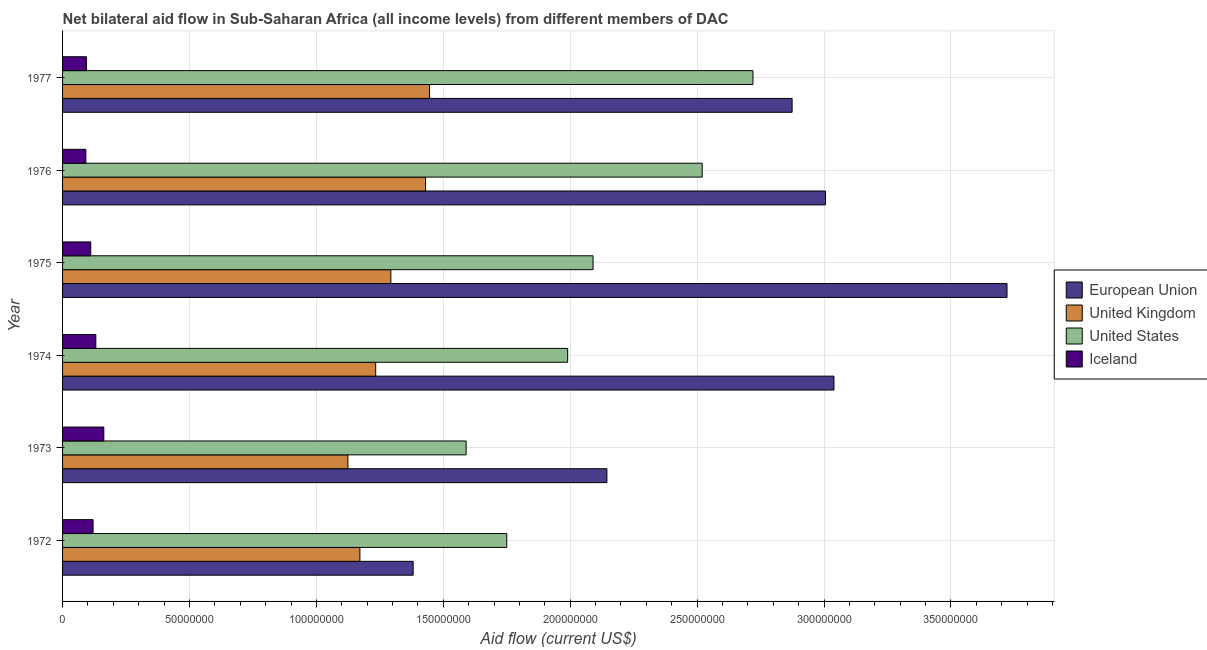Are the number of bars on each tick of the Y-axis equal?
Keep it short and to the point. Yes. How many bars are there on the 3rd tick from the top?
Offer a very short reply. 4. How many bars are there on the 2nd tick from the bottom?
Your answer should be compact. 4. What is the label of the 1st group of bars from the top?
Offer a very short reply. 1977. What is the amount of aid given by uk in 1976?
Make the answer very short. 1.43e+08. Across all years, what is the maximum amount of aid given by us?
Keep it short and to the point. 2.72e+08. Across all years, what is the minimum amount of aid given by us?
Your response must be concise. 1.59e+08. In which year was the amount of aid given by iceland maximum?
Provide a short and direct response. 1973. What is the total amount of aid given by iceland in the graph?
Keep it short and to the point. 7.10e+07. What is the difference between the amount of aid given by iceland in 1972 and that in 1973?
Offer a very short reply. -4.23e+06. What is the difference between the amount of aid given by us in 1972 and the amount of aid given by uk in 1976?
Your response must be concise. 3.20e+07. What is the average amount of aid given by iceland per year?
Keep it short and to the point. 1.18e+07. In the year 1974, what is the difference between the amount of aid given by eu and amount of aid given by us?
Your response must be concise. 1.05e+08. In how many years, is the amount of aid given by us greater than 160000000 US$?
Your answer should be very brief. 5. What is the ratio of the amount of aid given by us in 1972 to that in 1973?
Offer a very short reply. 1.1. Is the amount of aid given by us in 1972 less than that in 1974?
Offer a terse response. Yes. What is the difference between the highest and the second highest amount of aid given by eu?
Keep it short and to the point. 6.82e+07. What is the difference between the highest and the lowest amount of aid given by uk?
Your answer should be compact. 3.22e+07. In how many years, is the amount of aid given by iceland greater than the average amount of aid given by iceland taken over all years?
Provide a succinct answer. 3. Is it the case that in every year, the sum of the amount of aid given by uk and amount of aid given by eu is greater than the sum of amount of aid given by iceland and amount of aid given by us?
Your answer should be very brief. Yes. What does the 3rd bar from the top in 1977 represents?
Make the answer very short. United Kingdom. How many bars are there?
Your answer should be compact. 24. Are all the bars in the graph horizontal?
Your answer should be compact. Yes. Are the values on the major ticks of X-axis written in scientific E-notation?
Offer a very short reply. No. Does the graph contain grids?
Provide a short and direct response. Yes. How many legend labels are there?
Your answer should be compact. 4. What is the title of the graph?
Offer a very short reply. Net bilateral aid flow in Sub-Saharan Africa (all income levels) from different members of DAC. What is the label or title of the X-axis?
Your answer should be compact. Aid flow (current US$). What is the label or title of the Y-axis?
Make the answer very short. Year. What is the Aid flow (current US$) in European Union in 1972?
Give a very brief answer. 1.38e+08. What is the Aid flow (current US$) in United Kingdom in 1972?
Your answer should be compact. 1.17e+08. What is the Aid flow (current US$) of United States in 1972?
Offer a very short reply. 1.75e+08. What is the Aid flow (current US$) in Iceland in 1972?
Offer a terse response. 1.20e+07. What is the Aid flow (current US$) in European Union in 1973?
Your response must be concise. 2.14e+08. What is the Aid flow (current US$) in United Kingdom in 1973?
Your answer should be very brief. 1.12e+08. What is the Aid flow (current US$) in United States in 1973?
Offer a very short reply. 1.59e+08. What is the Aid flow (current US$) in Iceland in 1973?
Your answer should be very brief. 1.62e+07. What is the Aid flow (current US$) in European Union in 1974?
Your answer should be compact. 3.04e+08. What is the Aid flow (current US$) of United Kingdom in 1974?
Keep it short and to the point. 1.23e+08. What is the Aid flow (current US$) of United States in 1974?
Offer a terse response. 1.99e+08. What is the Aid flow (current US$) in Iceland in 1974?
Your answer should be very brief. 1.31e+07. What is the Aid flow (current US$) of European Union in 1975?
Offer a terse response. 3.72e+08. What is the Aid flow (current US$) of United Kingdom in 1975?
Give a very brief answer. 1.29e+08. What is the Aid flow (current US$) in United States in 1975?
Offer a very short reply. 2.09e+08. What is the Aid flow (current US$) of Iceland in 1975?
Your response must be concise. 1.11e+07. What is the Aid flow (current US$) of European Union in 1976?
Offer a very short reply. 3.01e+08. What is the Aid flow (current US$) of United Kingdom in 1976?
Provide a short and direct response. 1.43e+08. What is the Aid flow (current US$) of United States in 1976?
Make the answer very short. 2.52e+08. What is the Aid flow (current US$) of Iceland in 1976?
Ensure brevity in your answer.  9.18e+06. What is the Aid flow (current US$) of European Union in 1977?
Your answer should be compact. 2.87e+08. What is the Aid flow (current US$) in United Kingdom in 1977?
Offer a very short reply. 1.45e+08. What is the Aid flow (current US$) of United States in 1977?
Offer a terse response. 2.72e+08. What is the Aid flow (current US$) in Iceland in 1977?
Offer a very short reply. 9.40e+06. Across all years, what is the maximum Aid flow (current US$) of European Union?
Give a very brief answer. 3.72e+08. Across all years, what is the maximum Aid flow (current US$) of United Kingdom?
Give a very brief answer. 1.45e+08. Across all years, what is the maximum Aid flow (current US$) in United States?
Offer a terse response. 2.72e+08. Across all years, what is the maximum Aid flow (current US$) in Iceland?
Provide a succinct answer. 1.62e+07. Across all years, what is the minimum Aid flow (current US$) of European Union?
Keep it short and to the point. 1.38e+08. Across all years, what is the minimum Aid flow (current US$) of United Kingdom?
Provide a succinct answer. 1.12e+08. Across all years, what is the minimum Aid flow (current US$) of United States?
Keep it short and to the point. 1.59e+08. Across all years, what is the minimum Aid flow (current US$) in Iceland?
Your answer should be compact. 9.18e+06. What is the total Aid flow (current US$) of European Union in the graph?
Offer a very short reply. 1.62e+09. What is the total Aid flow (current US$) in United Kingdom in the graph?
Make the answer very short. 7.70e+08. What is the total Aid flow (current US$) in United States in the graph?
Keep it short and to the point. 1.27e+09. What is the total Aid flow (current US$) in Iceland in the graph?
Your response must be concise. 7.10e+07. What is the difference between the Aid flow (current US$) in European Union in 1972 and that in 1973?
Offer a terse response. -7.63e+07. What is the difference between the Aid flow (current US$) of United Kingdom in 1972 and that in 1973?
Give a very brief answer. 4.72e+06. What is the difference between the Aid flow (current US$) in United States in 1972 and that in 1973?
Your response must be concise. 1.60e+07. What is the difference between the Aid flow (current US$) of Iceland in 1972 and that in 1973?
Give a very brief answer. -4.23e+06. What is the difference between the Aid flow (current US$) in European Union in 1972 and that in 1974?
Your answer should be compact. -1.66e+08. What is the difference between the Aid flow (current US$) in United Kingdom in 1972 and that in 1974?
Provide a succinct answer. -6.23e+06. What is the difference between the Aid flow (current US$) in United States in 1972 and that in 1974?
Your response must be concise. -2.40e+07. What is the difference between the Aid flow (current US$) of Iceland in 1972 and that in 1974?
Your answer should be compact. -1.08e+06. What is the difference between the Aid flow (current US$) in European Union in 1972 and that in 1975?
Your answer should be very brief. -2.34e+08. What is the difference between the Aid flow (current US$) in United Kingdom in 1972 and that in 1975?
Ensure brevity in your answer.  -1.22e+07. What is the difference between the Aid flow (current US$) of United States in 1972 and that in 1975?
Provide a short and direct response. -3.40e+07. What is the difference between the Aid flow (current US$) in Iceland in 1972 and that in 1975?
Give a very brief answer. 9.20e+05. What is the difference between the Aid flow (current US$) of European Union in 1972 and that in 1976?
Your answer should be compact. -1.62e+08. What is the difference between the Aid flow (current US$) in United Kingdom in 1972 and that in 1976?
Your answer should be compact. -2.59e+07. What is the difference between the Aid flow (current US$) in United States in 1972 and that in 1976?
Provide a short and direct response. -7.70e+07. What is the difference between the Aid flow (current US$) in Iceland in 1972 and that in 1976?
Provide a short and direct response. 2.84e+06. What is the difference between the Aid flow (current US$) in European Union in 1972 and that in 1977?
Your answer should be very brief. -1.49e+08. What is the difference between the Aid flow (current US$) in United Kingdom in 1972 and that in 1977?
Provide a succinct answer. -2.74e+07. What is the difference between the Aid flow (current US$) of United States in 1972 and that in 1977?
Give a very brief answer. -9.70e+07. What is the difference between the Aid flow (current US$) of Iceland in 1972 and that in 1977?
Ensure brevity in your answer.  2.62e+06. What is the difference between the Aid flow (current US$) in European Union in 1973 and that in 1974?
Give a very brief answer. -8.95e+07. What is the difference between the Aid flow (current US$) in United Kingdom in 1973 and that in 1974?
Make the answer very short. -1.10e+07. What is the difference between the Aid flow (current US$) of United States in 1973 and that in 1974?
Give a very brief answer. -4.00e+07. What is the difference between the Aid flow (current US$) in Iceland in 1973 and that in 1974?
Provide a short and direct response. 3.15e+06. What is the difference between the Aid flow (current US$) in European Union in 1973 and that in 1975?
Your answer should be very brief. -1.58e+08. What is the difference between the Aid flow (current US$) of United Kingdom in 1973 and that in 1975?
Your answer should be compact. -1.69e+07. What is the difference between the Aid flow (current US$) in United States in 1973 and that in 1975?
Offer a terse response. -5.00e+07. What is the difference between the Aid flow (current US$) in Iceland in 1973 and that in 1975?
Provide a succinct answer. 5.15e+06. What is the difference between the Aid flow (current US$) of European Union in 1973 and that in 1976?
Offer a terse response. -8.61e+07. What is the difference between the Aid flow (current US$) in United Kingdom in 1973 and that in 1976?
Your answer should be very brief. -3.06e+07. What is the difference between the Aid flow (current US$) in United States in 1973 and that in 1976?
Your answer should be compact. -9.30e+07. What is the difference between the Aid flow (current US$) of Iceland in 1973 and that in 1976?
Provide a succinct answer. 7.07e+06. What is the difference between the Aid flow (current US$) in European Union in 1973 and that in 1977?
Offer a very short reply. -7.30e+07. What is the difference between the Aid flow (current US$) of United Kingdom in 1973 and that in 1977?
Offer a terse response. -3.22e+07. What is the difference between the Aid flow (current US$) of United States in 1973 and that in 1977?
Keep it short and to the point. -1.13e+08. What is the difference between the Aid flow (current US$) in Iceland in 1973 and that in 1977?
Keep it short and to the point. 6.85e+06. What is the difference between the Aid flow (current US$) of European Union in 1974 and that in 1975?
Offer a terse response. -6.82e+07. What is the difference between the Aid flow (current US$) of United Kingdom in 1974 and that in 1975?
Make the answer very short. -5.97e+06. What is the difference between the Aid flow (current US$) of United States in 1974 and that in 1975?
Provide a short and direct response. -1.00e+07. What is the difference between the Aid flow (current US$) in European Union in 1974 and that in 1976?
Your answer should be very brief. 3.34e+06. What is the difference between the Aid flow (current US$) of United Kingdom in 1974 and that in 1976?
Your answer should be very brief. -1.96e+07. What is the difference between the Aid flow (current US$) of United States in 1974 and that in 1976?
Your answer should be compact. -5.30e+07. What is the difference between the Aid flow (current US$) in Iceland in 1974 and that in 1976?
Provide a short and direct response. 3.92e+06. What is the difference between the Aid flow (current US$) in European Union in 1974 and that in 1977?
Your answer should be very brief. 1.65e+07. What is the difference between the Aid flow (current US$) in United Kingdom in 1974 and that in 1977?
Make the answer very short. -2.12e+07. What is the difference between the Aid flow (current US$) in United States in 1974 and that in 1977?
Your answer should be compact. -7.30e+07. What is the difference between the Aid flow (current US$) in Iceland in 1974 and that in 1977?
Provide a short and direct response. 3.70e+06. What is the difference between the Aid flow (current US$) in European Union in 1975 and that in 1976?
Provide a succinct answer. 7.15e+07. What is the difference between the Aid flow (current US$) of United Kingdom in 1975 and that in 1976?
Your answer should be very brief. -1.37e+07. What is the difference between the Aid flow (current US$) of United States in 1975 and that in 1976?
Provide a succinct answer. -4.30e+07. What is the difference between the Aid flow (current US$) in Iceland in 1975 and that in 1976?
Provide a succinct answer. 1.92e+06. What is the difference between the Aid flow (current US$) of European Union in 1975 and that in 1977?
Make the answer very short. 8.47e+07. What is the difference between the Aid flow (current US$) in United Kingdom in 1975 and that in 1977?
Give a very brief answer. -1.52e+07. What is the difference between the Aid flow (current US$) of United States in 1975 and that in 1977?
Keep it short and to the point. -6.30e+07. What is the difference between the Aid flow (current US$) of Iceland in 1975 and that in 1977?
Offer a terse response. 1.70e+06. What is the difference between the Aid flow (current US$) of European Union in 1976 and that in 1977?
Your response must be concise. 1.32e+07. What is the difference between the Aid flow (current US$) in United Kingdom in 1976 and that in 1977?
Make the answer very short. -1.58e+06. What is the difference between the Aid flow (current US$) of United States in 1976 and that in 1977?
Offer a very short reply. -2.00e+07. What is the difference between the Aid flow (current US$) of Iceland in 1976 and that in 1977?
Your answer should be compact. -2.20e+05. What is the difference between the Aid flow (current US$) in European Union in 1972 and the Aid flow (current US$) in United Kingdom in 1973?
Ensure brevity in your answer.  2.57e+07. What is the difference between the Aid flow (current US$) in European Union in 1972 and the Aid flow (current US$) in United States in 1973?
Provide a succinct answer. -2.09e+07. What is the difference between the Aid flow (current US$) in European Union in 1972 and the Aid flow (current US$) in Iceland in 1973?
Your answer should be very brief. 1.22e+08. What is the difference between the Aid flow (current US$) in United Kingdom in 1972 and the Aid flow (current US$) in United States in 1973?
Provide a short and direct response. -4.19e+07. What is the difference between the Aid flow (current US$) in United Kingdom in 1972 and the Aid flow (current US$) in Iceland in 1973?
Provide a succinct answer. 1.01e+08. What is the difference between the Aid flow (current US$) in United States in 1972 and the Aid flow (current US$) in Iceland in 1973?
Your answer should be compact. 1.59e+08. What is the difference between the Aid flow (current US$) in European Union in 1972 and the Aid flow (current US$) in United Kingdom in 1974?
Keep it short and to the point. 1.48e+07. What is the difference between the Aid flow (current US$) of European Union in 1972 and the Aid flow (current US$) of United States in 1974?
Your answer should be compact. -6.09e+07. What is the difference between the Aid flow (current US$) of European Union in 1972 and the Aid flow (current US$) of Iceland in 1974?
Your answer should be very brief. 1.25e+08. What is the difference between the Aid flow (current US$) in United Kingdom in 1972 and the Aid flow (current US$) in United States in 1974?
Keep it short and to the point. -8.19e+07. What is the difference between the Aid flow (current US$) of United Kingdom in 1972 and the Aid flow (current US$) of Iceland in 1974?
Your answer should be very brief. 1.04e+08. What is the difference between the Aid flow (current US$) of United States in 1972 and the Aid flow (current US$) of Iceland in 1974?
Your response must be concise. 1.62e+08. What is the difference between the Aid flow (current US$) in European Union in 1972 and the Aid flow (current US$) in United Kingdom in 1975?
Your answer should be compact. 8.79e+06. What is the difference between the Aid flow (current US$) in European Union in 1972 and the Aid flow (current US$) in United States in 1975?
Offer a terse response. -7.09e+07. What is the difference between the Aid flow (current US$) of European Union in 1972 and the Aid flow (current US$) of Iceland in 1975?
Ensure brevity in your answer.  1.27e+08. What is the difference between the Aid flow (current US$) of United Kingdom in 1972 and the Aid flow (current US$) of United States in 1975?
Your response must be concise. -9.19e+07. What is the difference between the Aid flow (current US$) of United Kingdom in 1972 and the Aid flow (current US$) of Iceland in 1975?
Your answer should be compact. 1.06e+08. What is the difference between the Aid flow (current US$) of United States in 1972 and the Aid flow (current US$) of Iceland in 1975?
Provide a succinct answer. 1.64e+08. What is the difference between the Aid flow (current US$) in European Union in 1972 and the Aid flow (current US$) in United Kingdom in 1976?
Your answer should be compact. -4.87e+06. What is the difference between the Aid flow (current US$) in European Union in 1972 and the Aid flow (current US$) in United States in 1976?
Keep it short and to the point. -1.14e+08. What is the difference between the Aid flow (current US$) in European Union in 1972 and the Aid flow (current US$) in Iceland in 1976?
Give a very brief answer. 1.29e+08. What is the difference between the Aid flow (current US$) of United Kingdom in 1972 and the Aid flow (current US$) of United States in 1976?
Provide a short and direct response. -1.35e+08. What is the difference between the Aid flow (current US$) of United Kingdom in 1972 and the Aid flow (current US$) of Iceland in 1976?
Offer a terse response. 1.08e+08. What is the difference between the Aid flow (current US$) in United States in 1972 and the Aid flow (current US$) in Iceland in 1976?
Your response must be concise. 1.66e+08. What is the difference between the Aid flow (current US$) in European Union in 1972 and the Aid flow (current US$) in United Kingdom in 1977?
Ensure brevity in your answer.  -6.45e+06. What is the difference between the Aid flow (current US$) in European Union in 1972 and the Aid flow (current US$) in United States in 1977?
Keep it short and to the point. -1.34e+08. What is the difference between the Aid flow (current US$) in European Union in 1972 and the Aid flow (current US$) in Iceland in 1977?
Give a very brief answer. 1.29e+08. What is the difference between the Aid flow (current US$) in United Kingdom in 1972 and the Aid flow (current US$) in United States in 1977?
Your response must be concise. -1.55e+08. What is the difference between the Aid flow (current US$) of United Kingdom in 1972 and the Aid flow (current US$) of Iceland in 1977?
Offer a very short reply. 1.08e+08. What is the difference between the Aid flow (current US$) of United States in 1972 and the Aid flow (current US$) of Iceland in 1977?
Keep it short and to the point. 1.66e+08. What is the difference between the Aid flow (current US$) of European Union in 1973 and the Aid flow (current US$) of United Kingdom in 1974?
Your answer should be compact. 9.11e+07. What is the difference between the Aid flow (current US$) of European Union in 1973 and the Aid flow (current US$) of United States in 1974?
Make the answer very short. 1.55e+07. What is the difference between the Aid flow (current US$) of European Union in 1973 and the Aid flow (current US$) of Iceland in 1974?
Offer a terse response. 2.01e+08. What is the difference between the Aid flow (current US$) of United Kingdom in 1973 and the Aid flow (current US$) of United States in 1974?
Your answer should be compact. -8.66e+07. What is the difference between the Aid flow (current US$) of United Kingdom in 1973 and the Aid flow (current US$) of Iceland in 1974?
Ensure brevity in your answer.  9.93e+07. What is the difference between the Aid flow (current US$) of United States in 1973 and the Aid flow (current US$) of Iceland in 1974?
Provide a short and direct response. 1.46e+08. What is the difference between the Aid flow (current US$) in European Union in 1973 and the Aid flow (current US$) in United Kingdom in 1975?
Provide a succinct answer. 8.51e+07. What is the difference between the Aid flow (current US$) of European Union in 1973 and the Aid flow (current US$) of United States in 1975?
Make the answer very short. 5.46e+06. What is the difference between the Aid flow (current US$) of European Union in 1973 and the Aid flow (current US$) of Iceland in 1975?
Provide a succinct answer. 2.03e+08. What is the difference between the Aid flow (current US$) in United Kingdom in 1973 and the Aid flow (current US$) in United States in 1975?
Keep it short and to the point. -9.66e+07. What is the difference between the Aid flow (current US$) in United Kingdom in 1973 and the Aid flow (current US$) in Iceland in 1975?
Your answer should be compact. 1.01e+08. What is the difference between the Aid flow (current US$) in United States in 1973 and the Aid flow (current US$) in Iceland in 1975?
Offer a very short reply. 1.48e+08. What is the difference between the Aid flow (current US$) of European Union in 1973 and the Aid flow (current US$) of United Kingdom in 1976?
Ensure brevity in your answer.  7.15e+07. What is the difference between the Aid flow (current US$) of European Union in 1973 and the Aid flow (current US$) of United States in 1976?
Your answer should be compact. -3.75e+07. What is the difference between the Aid flow (current US$) of European Union in 1973 and the Aid flow (current US$) of Iceland in 1976?
Your response must be concise. 2.05e+08. What is the difference between the Aid flow (current US$) of United Kingdom in 1973 and the Aid flow (current US$) of United States in 1976?
Provide a succinct answer. -1.40e+08. What is the difference between the Aid flow (current US$) of United Kingdom in 1973 and the Aid flow (current US$) of Iceland in 1976?
Your answer should be very brief. 1.03e+08. What is the difference between the Aid flow (current US$) of United States in 1973 and the Aid flow (current US$) of Iceland in 1976?
Offer a terse response. 1.50e+08. What is the difference between the Aid flow (current US$) of European Union in 1973 and the Aid flow (current US$) of United Kingdom in 1977?
Make the answer very short. 6.99e+07. What is the difference between the Aid flow (current US$) in European Union in 1973 and the Aid flow (current US$) in United States in 1977?
Your answer should be very brief. -5.75e+07. What is the difference between the Aid flow (current US$) of European Union in 1973 and the Aid flow (current US$) of Iceland in 1977?
Give a very brief answer. 2.05e+08. What is the difference between the Aid flow (current US$) of United Kingdom in 1973 and the Aid flow (current US$) of United States in 1977?
Give a very brief answer. -1.60e+08. What is the difference between the Aid flow (current US$) of United Kingdom in 1973 and the Aid flow (current US$) of Iceland in 1977?
Offer a very short reply. 1.03e+08. What is the difference between the Aid flow (current US$) in United States in 1973 and the Aid flow (current US$) in Iceland in 1977?
Provide a short and direct response. 1.50e+08. What is the difference between the Aid flow (current US$) of European Union in 1974 and the Aid flow (current US$) of United Kingdom in 1975?
Your response must be concise. 1.75e+08. What is the difference between the Aid flow (current US$) of European Union in 1974 and the Aid flow (current US$) of United States in 1975?
Your answer should be very brief. 9.49e+07. What is the difference between the Aid flow (current US$) of European Union in 1974 and the Aid flow (current US$) of Iceland in 1975?
Your response must be concise. 2.93e+08. What is the difference between the Aid flow (current US$) of United Kingdom in 1974 and the Aid flow (current US$) of United States in 1975?
Offer a very short reply. -8.56e+07. What is the difference between the Aid flow (current US$) of United Kingdom in 1974 and the Aid flow (current US$) of Iceland in 1975?
Provide a succinct answer. 1.12e+08. What is the difference between the Aid flow (current US$) of United States in 1974 and the Aid flow (current US$) of Iceland in 1975?
Keep it short and to the point. 1.88e+08. What is the difference between the Aid flow (current US$) of European Union in 1974 and the Aid flow (current US$) of United Kingdom in 1976?
Your response must be concise. 1.61e+08. What is the difference between the Aid flow (current US$) of European Union in 1974 and the Aid flow (current US$) of United States in 1976?
Offer a terse response. 5.19e+07. What is the difference between the Aid flow (current US$) of European Union in 1974 and the Aid flow (current US$) of Iceland in 1976?
Your response must be concise. 2.95e+08. What is the difference between the Aid flow (current US$) of United Kingdom in 1974 and the Aid flow (current US$) of United States in 1976?
Your answer should be very brief. -1.29e+08. What is the difference between the Aid flow (current US$) in United Kingdom in 1974 and the Aid flow (current US$) in Iceland in 1976?
Provide a short and direct response. 1.14e+08. What is the difference between the Aid flow (current US$) of United States in 1974 and the Aid flow (current US$) of Iceland in 1976?
Provide a succinct answer. 1.90e+08. What is the difference between the Aid flow (current US$) of European Union in 1974 and the Aid flow (current US$) of United Kingdom in 1977?
Ensure brevity in your answer.  1.59e+08. What is the difference between the Aid flow (current US$) of European Union in 1974 and the Aid flow (current US$) of United States in 1977?
Your answer should be compact. 3.19e+07. What is the difference between the Aid flow (current US$) in European Union in 1974 and the Aid flow (current US$) in Iceland in 1977?
Provide a short and direct response. 2.95e+08. What is the difference between the Aid flow (current US$) in United Kingdom in 1974 and the Aid flow (current US$) in United States in 1977?
Your answer should be very brief. -1.49e+08. What is the difference between the Aid flow (current US$) of United Kingdom in 1974 and the Aid flow (current US$) of Iceland in 1977?
Your answer should be very brief. 1.14e+08. What is the difference between the Aid flow (current US$) in United States in 1974 and the Aid flow (current US$) in Iceland in 1977?
Give a very brief answer. 1.90e+08. What is the difference between the Aid flow (current US$) in European Union in 1975 and the Aid flow (current US$) in United Kingdom in 1976?
Offer a very short reply. 2.29e+08. What is the difference between the Aid flow (current US$) in European Union in 1975 and the Aid flow (current US$) in United States in 1976?
Your answer should be very brief. 1.20e+08. What is the difference between the Aid flow (current US$) of European Union in 1975 and the Aid flow (current US$) of Iceland in 1976?
Offer a very short reply. 3.63e+08. What is the difference between the Aid flow (current US$) in United Kingdom in 1975 and the Aid flow (current US$) in United States in 1976?
Provide a succinct answer. -1.23e+08. What is the difference between the Aid flow (current US$) in United Kingdom in 1975 and the Aid flow (current US$) in Iceland in 1976?
Provide a succinct answer. 1.20e+08. What is the difference between the Aid flow (current US$) in United States in 1975 and the Aid flow (current US$) in Iceland in 1976?
Ensure brevity in your answer.  2.00e+08. What is the difference between the Aid flow (current US$) of European Union in 1975 and the Aid flow (current US$) of United Kingdom in 1977?
Offer a very short reply. 2.28e+08. What is the difference between the Aid flow (current US$) in European Union in 1975 and the Aid flow (current US$) in United States in 1977?
Offer a very short reply. 1.00e+08. What is the difference between the Aid flow (current US$) of European Union in 1975 and the Aid flow (current US$) of Iceland in 1977?
Offer a terse response. 3.63e+08. What is the difference between the Aid flow (current US$) of United Kingdom in 1975 and the Aid flow (current US$) of United States in 1977?
Provide a short and direct response. -1.43e+08. What is the difference between the Aid flow (current US$) of United Kingdom in 1975 and the Aid flow (current US$) of Iceland in 1977?
Provide a succinct answer. 1.20e+08. What is the difference between the Aid flow (current US$) of United States in 1975 and the Aid flow (current US$) of Iceland in 1977?
Your response must be concise. 2.00e+08. What is the difference between the Aid flow (current US$) of European Union in 1976 and the Aid flow (current US$) of United Kingdom in 1977?
Your answer should be compact. 1.56e+08. What is the difference between the Aid flow (current US$) of European Union in 1976 and the Aid flow (current US$) of United States in 1977?
Your answer should be very brief. 2.86e+07. What is the difference between the Aid flow (current US$) in European Union in 1976 and the Aid flow (current US$) in Iceland in 1977?
Offer a terse response. 2.91e+08. What is the difference between the Aid flow (current US$) in United Kingdom in 1976 and the Aid flow (current US$) in United States in 1977?
Keep it short and to the point. -1.29e+08. What is the difference between the Aid flow (current US$) of United Kingdom in 1976 and the Aid flow (current US$) of Iceland in 1977?
Ensure brevity in your answer.  1.34e+08. What is the difference between the Aid flow (current US$) in United States in 1976 and the Aid flow (current US$) in Iceland in 1977?
Provide a short and direct response. 2.43e+08. What is the average Aid flow (current US$) of European Union per year?
Give a very brief answer. 2.69e+08. What is the average Aid flow (current US$) in United Kingdom per year?
Your answer should be very brief. 1.28e+08. What is the average Aid flow (current US$) in United States per year?
Ensure brevity in your answer.  2.11e+08. What is the average Aid flow (current US$) of Iceland per year?
Provide a succinct answer. 1.18e+07. In the year 1972, what is the difference between the Aid flow (current US$) in European Union and Aid flow (current US$) in United Kingdom?
Ensure brevity in your answer.  2.10e+07. In the year 1972, what is the difference between the Aid flow (current US$) of European Union and Aid flow (current US$) of United States?
Make the answer very short. -3.69e+07. In the year 1972, what is the difference between the Aid flow (current US$) of European Union and Aid flow (current US$) of Iceland?
Offer a terse response. 1.26e+08. In the year 1972, what is the difference between the Aid flow (current US$) of United Kingdom and Aid flow (current US$) of United States?
Ensure brevity in your answer.  -5.79e+07. In the year 1972, what is the difference between the Aid flow (current US$) of United Kingdom and Aid flow (current US$) of Iceland?
Your response must be concise. 1.05e+08. In the year 1972, what is the difference between the Aid flow (current US$) in United States and Aid flow (current US$) in Iceland?
Your answer should be very brief. 1.63e+08. In the year 1973, what is the difference between the Aid flow (current US$) of European Union and Aid flow (current US$) of United Kingdom?
Make the answer very short. 1.02e+08. In the year 1973, what is the difference between the Aid flow (current US$) in European Union and Aid flow (current US$) in United States?
Keep it short and to the point. 5.55e+07. In the year 1973, what is the difference between the Aid flow (current US$) of European Union and Aid flow (current US$) of Iceland?
Your answer should be compact. 1.98e+08. In the year 1973, what is the difference between the Aid flow (current US$) of United Kingdom and Aid flow (current US$) of United States?
Provide a short and direct response. -4.66e+07. In the year 1973, what is the difference between the Aid flow (current US$) in United Kingdom and Aid flow (current US$) in Iceland?
Make the answer very short. 9.62e+07. In the year 1973, what is the difference between the Aid flow (current US$) of United States and Aid flow (current US$) of Iceland?
Offer a very short reply. 1.43e+08. In the year 1974, what is the difference between the Aid flow (current US$) of European Union and Aid flow (current US$) of United Kingdom?
Give a very brief answer. 1.81e+08. In the year 1974, what is the difference between the Aid flow (current US$) in European Union and Aid flow (current US$) in United States?
Your answer should be compact. 1.05e+08. In the year 1974, what is the difference between the Aid flow (current US$) of European Union and Aid flow (current US$) of Iceland?
Offer a very short reply. 2.91e+08. In the year 1974, what is the difference between the Aid flow (current US$) of United Kingdom and Aid flow (current US$) of United States?
Offer a very short reply. -7.56e+07. In the year 1974, what is the difference between the Aid flow (current US$) of United Kingdom and Aid flow (current US$) of Iceland?
Your response must be concise. 1.10e+08. In the year 1974, what is the difference between the Aid flow (current US$) of United States and Aid flow (current US$) of Iceland?
Your response must be concise. 1.86e+08. In the year 1975, what is the difference between the Aid flow (current US$) in European Union and Aid flow (current US$) in United Kingdom?
Provide a short and direct response. 2.43e+08. In the year 1975, what is the difference between the Aid flow (current US$) in European Union and Aid flow (current US$) in United States?
Make the answer very short. 1.63e+08. In the year 1975, what is the difference between the Aid flow (current US$) of European Union and Aid flow (current US$) of Iceland?
Your answer should be compact. 3.61e+08. In the year 1975, what is the difference between the Aid flow (current US$) of United Kingdom and Aid flow (current US$) of United States?
Your response must be concise. -7.97e+07. In the year 1975, what is the difference between the Aid flow (current US$) of United Kingdom and Aid flow (current US$) of Iceland?
Your answer should be very brief. 1.18e+08. In the year 1975, what is the difference between the Aid flow (current US$) of United States and Aid flow (current US$) of Iceland?
Give a very brief answer. 1.98e+08. In the year 1976, what is the difference between the Aid flow (current US$) in European Union and Aid flow (current US$) in United Kingdom?
Offer a terse response. 1.58e+08. In the year 1976, what is the difference between the Aid flow (current US$) in European Union and Aid flow (current US$) in United States?
Give a very brief answer. 4.86e+07. In the year 1976, what is the difference between the Aid flow (current US$) in European Union and Aid flow (current US$) in Iceland?
Offer a very short reply. 2.91e+08. In the year 1976, what is the difference between the Aid flow (current US$) of United Kingdom and Aid flow (current US$) of United States?
Your answer should be very brief. -1.09e+08. In the year 1976, what is the difference between the Aid flow (current US$) in United Kingdom and Aid flow (current US$) in Iceland?
Ensure brevity in your answer.  1.34e+08. In the year 1976, what is the difference between the Aid flow (current US$) in United States and Aid flow (current US$) in Iceland?
Your response must be concise. 2.43e+08. In the year 1977, what is the difference between the Aid flow (current US$) in European Union and Aid flow (current US$) in United Kingdom?
Keep it short and to the point. 1.43e+08. In the year 1977, what is the difference between the Aid flow (current US$) of European Union and Aid flow (current US$) of United States?
Provide a succinct answer. 1.54e+07. In the year 1977, what is the difference between the Aid flow (current US$) of European Union and Aid flow (current US$) of Iceland?
Ensure brevity in your answer.  2.78e+08. In the year 1977, what is the difference between the Aid flow (current US$) of United Kingdom and Aid flow (current US$) of United States?
Give a very brief answer. -1.27e+08. In the year 1977, what is the difference between the Aid flow (current US$) of United Kingdom and Aid flow (current US$) of Iceland?
Your response must be concise. 1.35e+08. In the year 1977, what is the difference between the Aid flow (current US$) of United States and Aid flow (current US$) of Iceland?
Your response must be concise. 2.63e+08. What is the ratio of the Aid flow (current US$) in European Union in 1972 to that in 1973?
Provide a succinct answer. 0.64. What is the ratio of the Aid flow (current US$) of United Kingdom in 1972 to that in 1973?
Ensure brevity in your answer.  1.04. What is the ratio of the Aid flow (current US$) in United States in 1972 to that in 1973?
Keep it short and to the point. 1.1. What is the ratio of the Aid flow (current US$) in Iceland in 1972 to that in 1973?
Make the answer very short. 0.74. What is the ratio of the Aid flow (current US$) in European Union in 1972 to that in 1974?
Your answer should be very brief. 0.45. What is the ratio of the Aid flow (current US$) of United Kingdom in 1972 to that in 1974?
Offer a very short reply. 0.95. What is the ratio of the Aid flow (current US$) of United States in 1972 to that in 1974?
Make the answer very short. 0.88. What is the ratio of the Aid flow (current US$) of Iceland in 1972 to that in 1974?
Ensure brevity in your answer.  0.92. What is the ratio of the Aid flow (current US$) of European Union in 1972 to that in 1975?
Provide a succinct answer. 0.37. What is the ratio of the Aid flow (current US$) in United Kingdom in 1972 to that in 1975?
Ensure brevity in your answer.  0.91. What is the ratio of the Aid flow (current US$) in United States in 1972 to that in 1975?
Your answer should be compact. 0.84. What is the ratio of the Aid flow (current US$) in Iceland in 1972 to that in 1975?
Offer a very short reply. 1.08. What is the ratio of the Aid flow (current US$) in European Union in 1972 to that in 1976?
Your answer should be compact. 0.46. What is the ratio of the Aid flow (current US$) of United Kingdom in 1972 to that in 1976?
Your response must be concise. 0.82. What is the ratio of the Aid flow (current US$) in United States in 1972 to that in 1976?
Make the answer very short. 0.69. What is the ratio of the Aid flow (current US$) in Iceland in 1972 to that in 1976?
Your answer should be compact. 1.31. What is the ratio of the Aid flow (current US$) in European Union in 1972 to that in 1977?
Your answer should be very brief. 0.48. What is the ratio of the Aid flow (current US$) in United Kingdom in 1972 to that in 1977?
Your response must be concise. 0.81. What is the ratio of the Aid flow (current US$) of United States in 1972 to that in 1977?
Your response must be concise. 0.64. What is the ratio of the Aid flow (current US$) of Iceland in 1972 to that in 1977?
Give a very brief answer. 1.28. What is the ratio of the Aid flow (current US$) of European Union in 1973 to that in 1974?
Your answer should be very brief. 0.71. What is the ratio of the Aid flow (current US$) in United Kingdom in 1973 to that in 1974?
Ensure brevity in your answer.  0.91. What is the ratio of the Aid flow (current US$) of United States in 1973 to that in 1974?
Give a very brief answer. 0.8. What is the ratio of the Aid flow (current US$) in Iceland in 1973 to that in 1974?
Provide a succinct answer. 1.24. What is the ratio of the Aid flow (current US$) in European Union in 1973 to that in 1975?
Provide a short and direct response. 0.58. What is the ratio of the Aid flow (current US$) of United Kingdom in 1973 to that in 1975?
Give a very brief answer. 0.87. What is the ratio of the Aid flow (current US$) in United States in 1973 to that in 1975?
Offer a very short reply. 0.76. What is the ratio of the Aid flow (current US$) in Iceland in 1973 to that in 1975?
Ensure brevity in your answer.  1.46. What is the ratio of the Aid flow (current US$) of European Union in 1973 to that in 1976?
Your answer should be very brief. 0.71. What is the ratio of the Aid flow (current US$) in United Kingdom in 1973 to that in 1976?
Offer a terse response. 0.79. What is the ratio of the Aid flow (current US$) of United States in 1973 to that in 1976?
Your answer should be compact. 0.63. What is the ratio of the Aid flow (current US$) of Iceland in 1973 to that in 1976?
Your response must be concise. 1.77. What is the ratio of the Aid flow (current US$) of European Union in 1973 to that in 1977?
Give a very brief answer. 0.75. What is the ratio of the Aid flow (current US$) in United Kingdom in 1973 to that in 1977?
Provide a short and direct response. 0.78. What is the ratio of the Aid flow (current US$) of United States in 1973 to that in 1977?
Provide a short and direct response. 0.58. What is the ratio of the Aid flow (current US$) in Iceland in 1973 to that in 1977?
Keep it short and to the point. 1.73. What is the ratio of the Aid flow (current US$) in European Union in 1974 to that in 1975?
Make the answer very short. 0.82. What is the ratio of the Aid flow (current US$) in United Kingdom in 1974 to that in 1975?
Make the answer very short. 0.95. What is the ratio of the Aid flow (current US$) of United States in 1974 to that in 1975?
Your answer should be very brief. 0.95. What is the ratio of the Aid flow (current US$) of Iceland in 1974 to that in 1975?
Your response must be concise. 1.18. What is the ratio of the Aid flow (current US$) in European Union in 1974 to that in 1976?
Your response must be concise. 1.01. What is the ratio of the Aid flow (current US$) in United Kingdom in 1974 to that in 1976?
Your answer should be very brief. 0.86. What is the ratio of the Aid flow (current US$) in United States in 1974 to that in 1976?
Your response must be concise. 0.79. What is the ratio of the Aid flow (current US$) of Iceland in 1974 to that in 1976?
Provide a succinct answer. 1.43. What is the ratio of the Aid flow (current US$) in European Union in 1974 to that in 1977?
Your answer should be compact. 1.06. What is the ratio of the Aid flow (current US$) in United Kingdom in 1974 to that in 1977?
Provide a succinct answer. 0.85. What is the ratio of the Aid flow (current US$) in United States in 1974 to that in 1977?
Keep it short and to the point. 0.73. What is the ratio of the Aid flow (current US$) in Iceland in 1974 to that in 1977?
Provide a succinct answer. 1.39. What is the ratio of the Aid flow (current US$) of European Union in 1975 to that in 1976?
Provide a succinct answer. 1.24. What is the ratio of the Aid flow (current US$) of United Kingdom in 1975 to that in 1976?
Offer a terse response. 0.9. What is the ratio of the Aid flow (current US$) in United States in 1975 to that in 1976?
Ensure brevity in your answer.  0.83. What is the ratio of the Aid flow (current US$) in Iceland in 1975 to that in 1976?
Your answer should be very brief. 1.21. What is the ratio of the Aid flow (current US$) of European Union in 1975 to that in 1977?
Make the answer very short. 1.29. What is the ratio of the Aid flow (current US$) of United Kingdom in 1975 to that in 1977?
Give a very brief answer. 0.89. What is the ratio of the Aid flow (current US$) of United States in 1975 to that in 1977?
Provide a succinct answer. 0.77. What is the ratio of the Aid flow (current US$) in Iceland in 1975 to that in 1977?
Your answer should be very brief. 1.18. What is the ratio of the Aid flow (current US$) in European Union in 1976 to that in 1977?
Your response must be concise. 1.05. What is the ratio of the Aid flow (current US$) in United States in 1976 to that in 1977?
Keep it short and to the point. 0.93. What is the ratio of the Aid flow (current US$) of Iceland in 1976 to that in 1977?
Offer a very short reply. 0.98. What is the difference between the highest and the second highest Aid flow (current US$) of European Union?
Your response must be concise. 6.82e+07. What is the difference between the highest and the second highest Aid flow (current US$) of United Kingdom?
Offer a terse response. 1.58e+06. What is the difference between the highest and the second highest Aid flow (current US$) of Iceland?
Your answer should be very brief. 3.15e+06. What is the difference between the highest and the lowest Aid flow (current US$) in European Union?
Your answer should be compact. 2.34e+08. What is the difference between the highest and the lowest Aid flow (current US$) of United Kingdom?
Your response must be concise. 3.22e+07. What is the difference between the highest and the lowest Aid flow (current US$) in United States?
Provide a succinct answer. 1.13e+08. What is the difference between the highest and the lowest Aid flow (current US$) of Iceland?
Offer a terse response. 7.07e+06. 